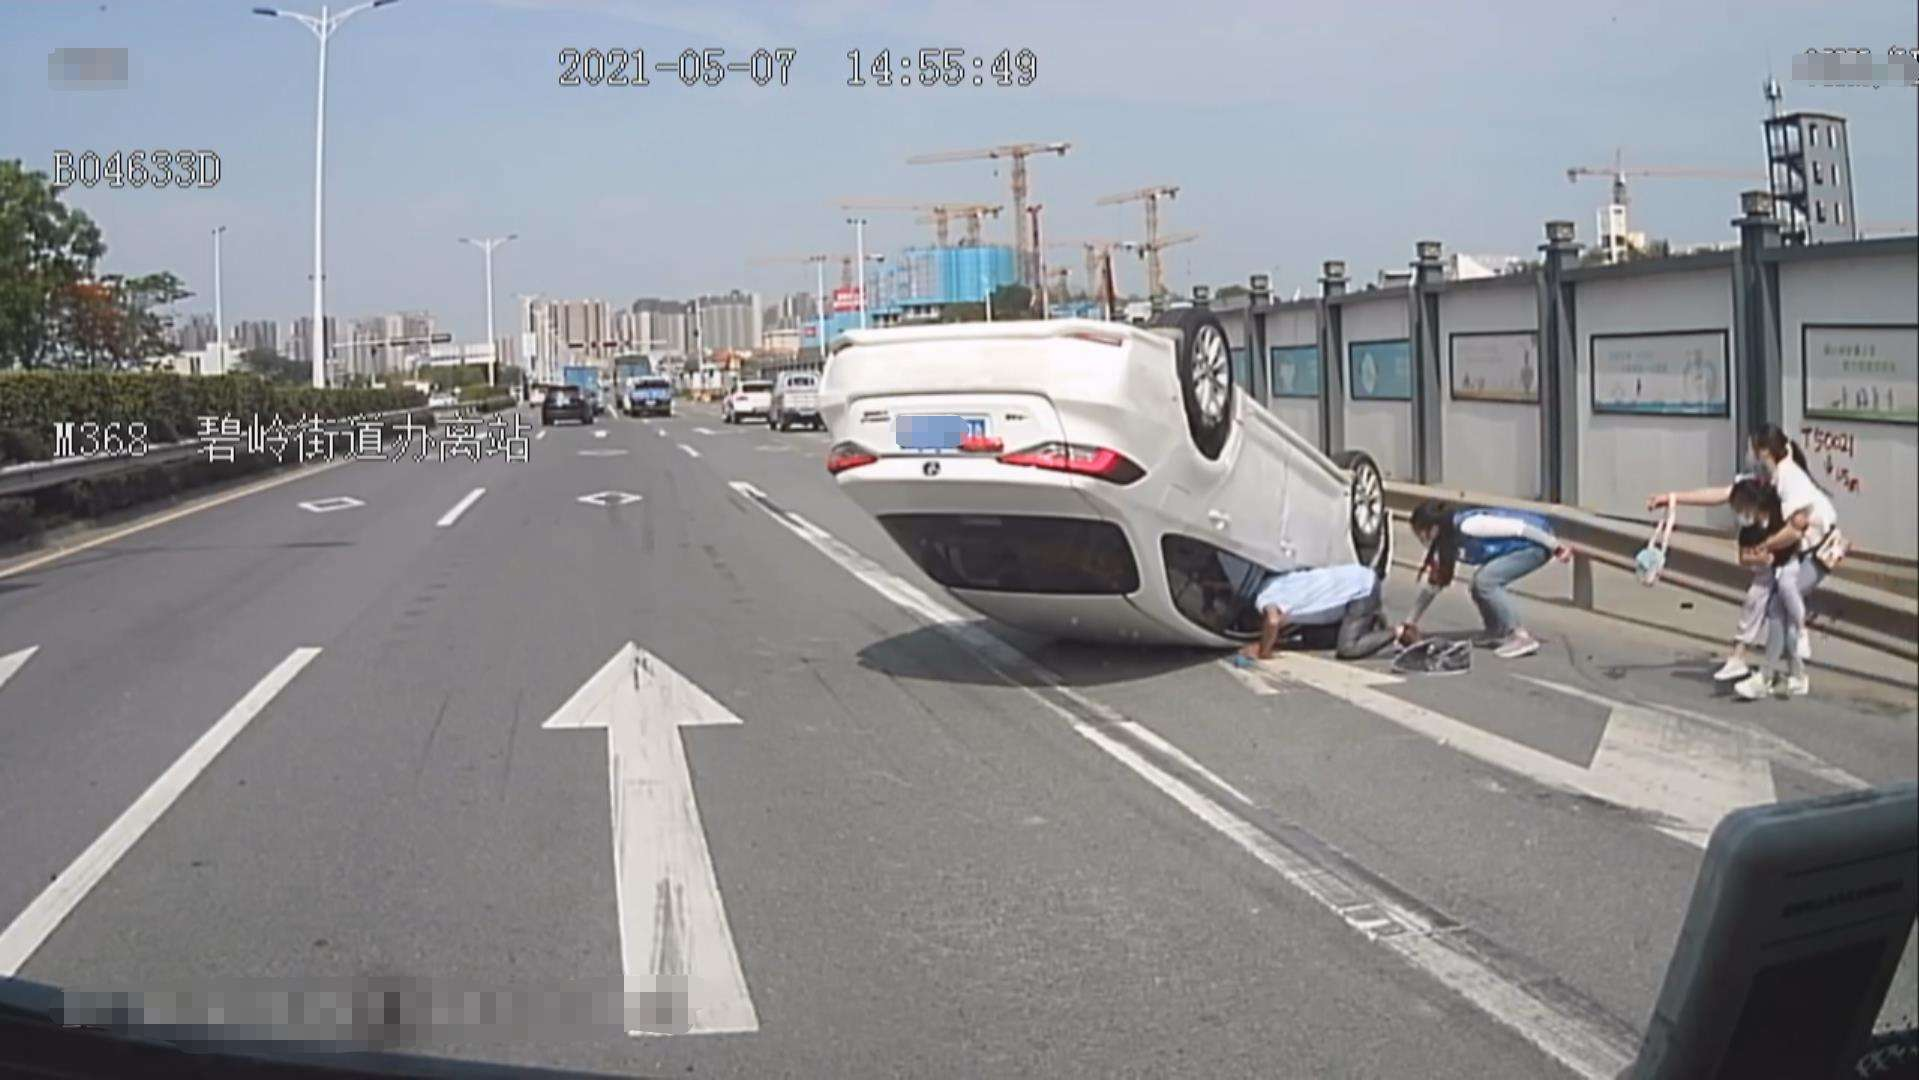What happened in the image? The image shows a road accident where a white car is flipped onto its roof. Several people are present around the car, which suggests they are either witnesses to the accident or are helping with the aftermath. The setting of the photo, including the road infrastructure and vehicles, suggests this is an urban area. 